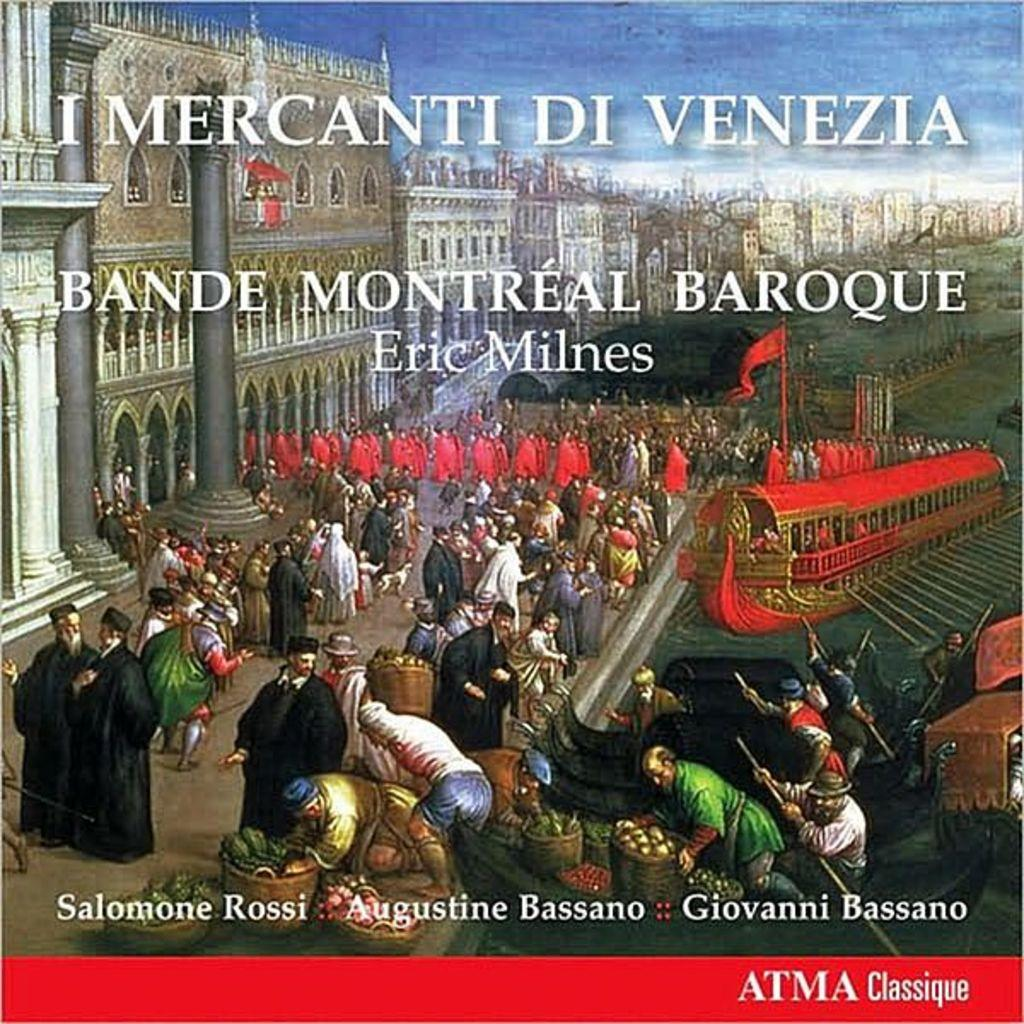<image>
Create a compact narrative representing the image presented. An historic book called I Mercanti DiVenezia which has three authors. 